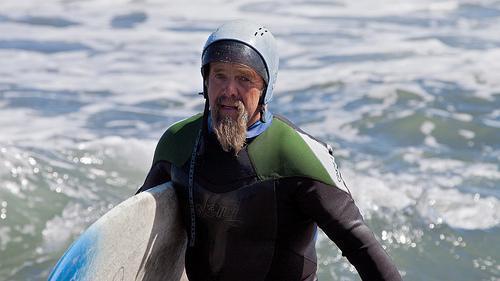How many colors are on the surfboard?
Give a very brief answer. 2. 